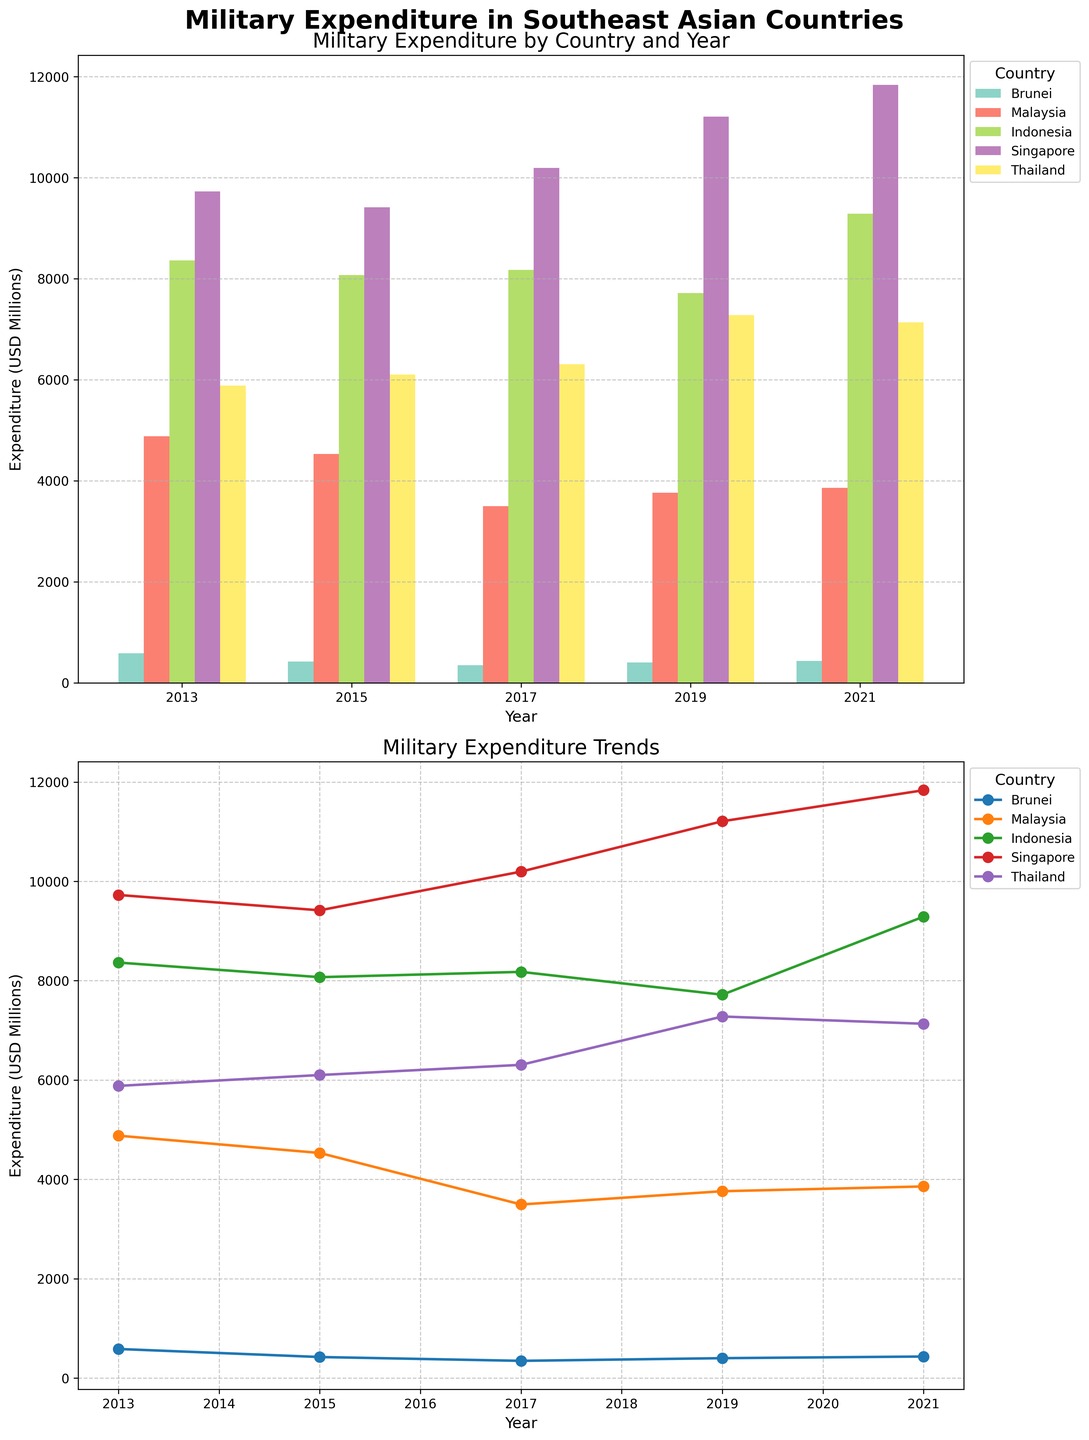What is the overall title of the figure? The overall title is located at the top center of the figure, usually in larger font and sometimes bold to draw attention.
Answer: Military Expenditure in Southeast Asian Countries How many countries are compared in the figure? Count the distinct labels in the legend or look for distinct color-coded bars and lines corresponding to each country.
Answer: Five What is the general trend of Brunei's military expenditure from 2013 to 2021? Observe the line plot's slope for Brunei from 2013 to 2021 to see if it is increasing, decreasing, or stable.
Answer: Decreasing initially, then slightly increasing Which country had the highest military expenditure in 2021? Look at the line plot or bar corresponding to the year 2021 and identify the country with the highest value.
Answer: Singapore What is the difference in military expenditure between Brunei and Malaysia in 2013? Find the bar or point values for Brunei and Malaysia in 2013 and subtract the smaller value from the larger one. The respective expenditures are Brunei: 586 and Malaysia: 4880.
Answer: 4294 Million USD Which country had the most significant increase in military expenditure between 2013 and 2021? Compare the values for each country between 2013 and 2021 and identify which country’s value increased the most.
Answer: Singapore What is the trend of military expenditure for Singapore from 2013 to 2021? Observe the sequence of points for Singapore in the line plot to determine the trend over time.
Answer: Increasing How does the military expenditure of Brunei in 2019 compare to that in 2015? Look at the bar or point values for Brunei in 2015 and 2019 and compare them. Brunei's expenditures are 424 in 2015 and 401 in 2019.
Answer: Decreased Which countries showed a slight fluctuation in their military expenditure over the years instead of a clear trend? Look at the lines for each country in the line plot and identify those that show up-and-down patterns rather than a clear upward or downward trend.
Answer: Indonesia and Malaysia What could be a potential reason for the higher military expenditure of Singapore compared to Brunei? This question requires contextual knowledge and inference. Generally, consider factors like geopolitical situations, economic capacity, population size, and strategic needs.
Answer: Geopolitical importance, economic capacity 